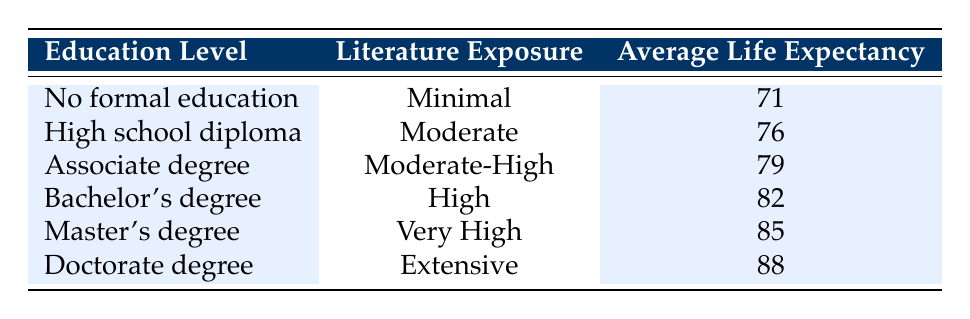What is the average life expectancy for individuals with a Master's degree? The table states that individuals with a Master's degree have an average life expectancy of 85.
Answer: 85 What education level corresponds to an average life expectancy of 79? According to the table, an average life expectancy of 79 corresponds to individuals with an Associate degree.
Answer: Associate degree How much longer do people with a Doctorate degree live compared to those with no formal education? The average life expectancy for individuals with a Doctorate degree is 88, and for those with no formal education, it's 71. The difference is 88 - 71 = 17 years.
Answer: 17 years Is it true that individuals with "High school diploma" have a longer average life expectancy than those with "No formal education"? Yes, since individuals with a High school diploma have an average life expectancy of 76, while those with no formal education have an average of 71.
Answer: Yes What can be inferred about the relationship between education level and literature exposure from the table? The table shows a clear trend where higher education levels correspond to greater literature exposure, with both factors increasing average life expectancy.
Answer: Literature exposure increases with education level 